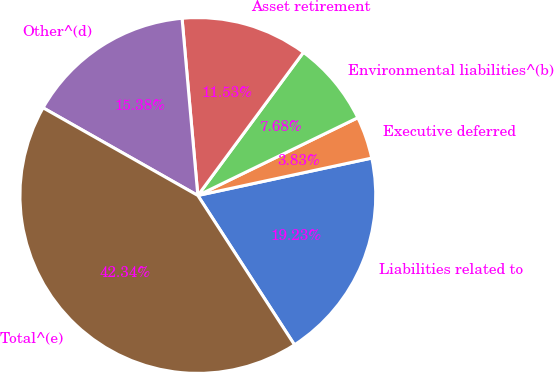<chart> <loc_0><loc_0><loc_500><loc_500><pie_chart><fcel>Liabilities related to<fcel>Executive deferred<fcel>Environmental liabilities^(b)<fcel>Asset retirement<fcel>Other^(d)<fcel>Total^(e)<nl><fcel>19.23%<fcel>3.83%<fcel>7.68%<fcel>11.53%<fcel>15.38%<fcel>42.34%<nl></chart> 